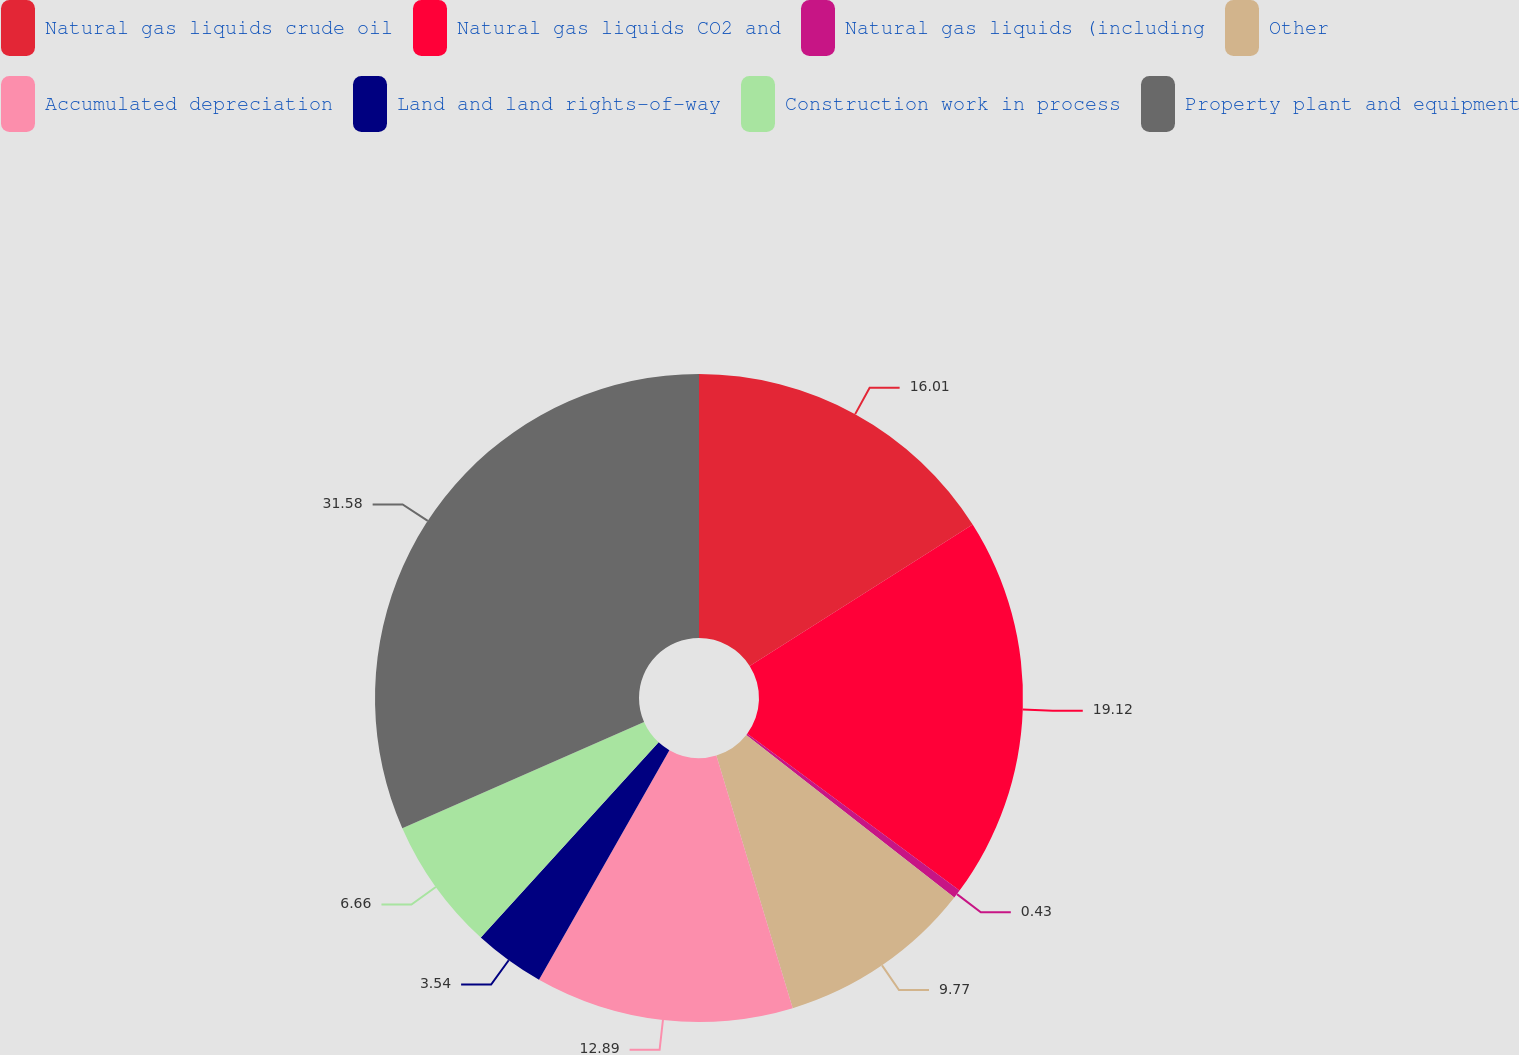<chart> <loc_0><loc_0><loc_500><loc_500><pie_chart><fcel>Natural gas liquids crude oil<fcel>Natural gas liquids CO2 and<fcel>Natural gas liquids (including<fcel>Other<fcel>Accumulated depreciation<fcel>Land and land rights-of-way<fcel>Construction work in process<fcel>Property plant and equipment<nl><fcel>16.01%<fcel>19.12%<fcel>0.43%<fcel>9.77%<fcel>12.89%<fcel>3.54%<fcel>6.66%<fcel>31.58%<nl></chart> 